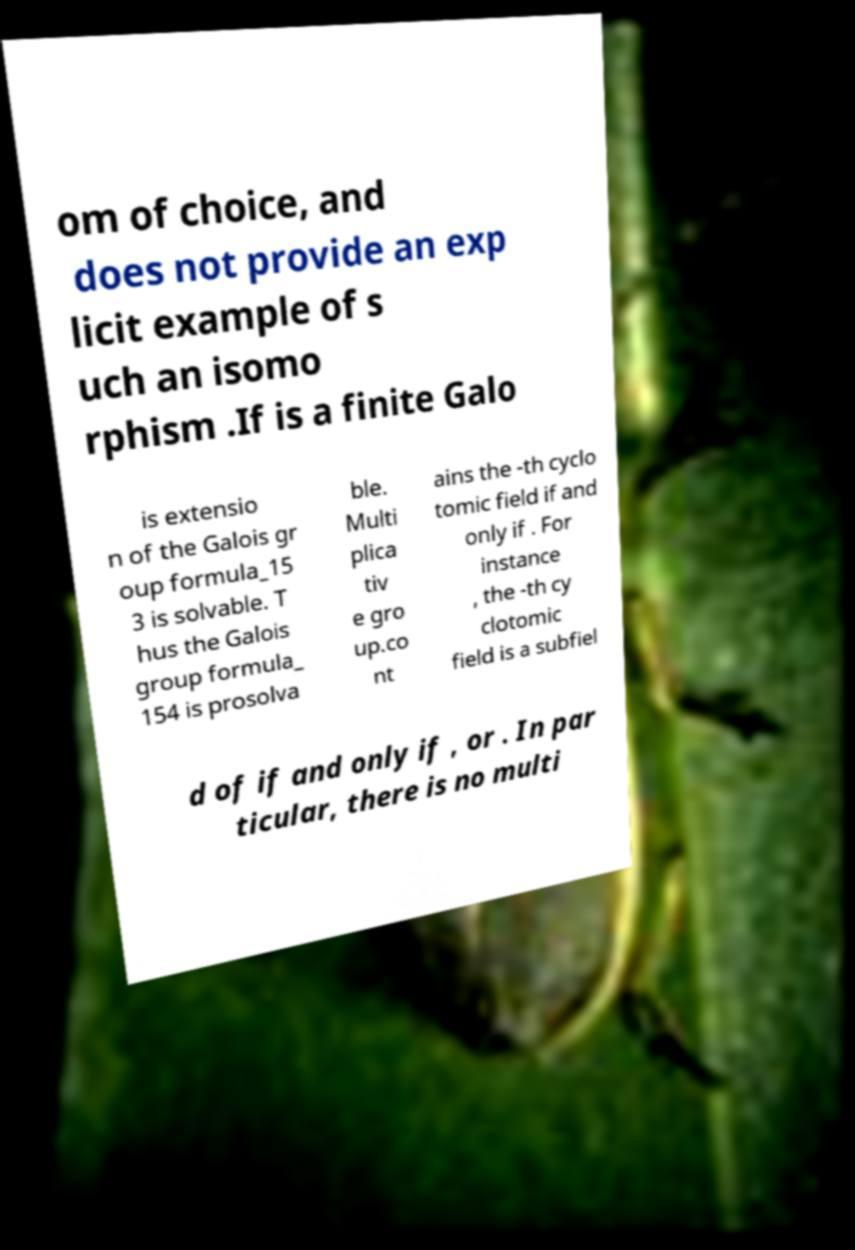Could you assist in decoding the text presented in this image and type it out clearly? om of choice, and does not provide an exp licit example of s uch an isomo rphism .If is a finite Galo is extensio n of the Galois gr oup formula_15 3 is solvable. T hus the Galois group formula_ 154 is prosolva ble. Multi plica tiv e gro up.co nt ains the -th cyclo tomic field if and only if . For instance , the -th cy clotomic field is a subfiel d of if and only if , or . In par ticular, there is no multi 